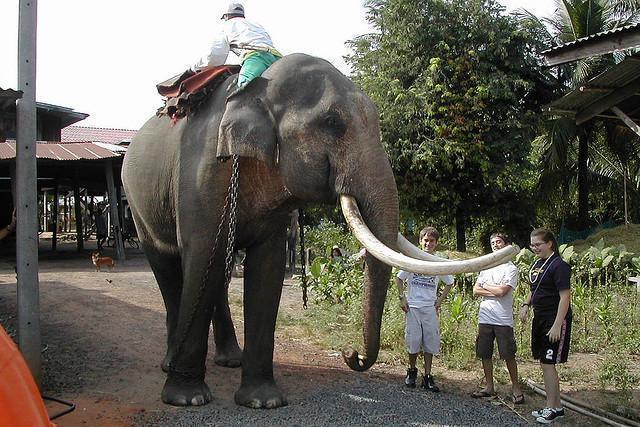Why is it unusual for elephants to have tusks this big?
Answer the question by selecting the correct answer among the 4 following choices.
Options: Attracts poachers, grooming habits, impossibility, abnormality. Attracts poachers. 